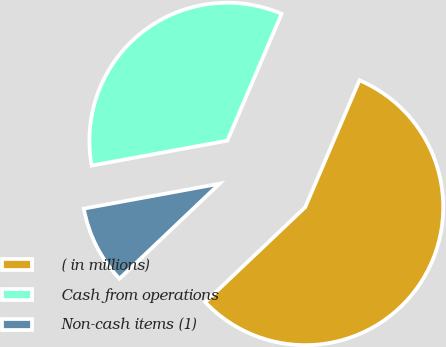<chart> <loc_0><loc_0><loc_500><loc_500><pie_chart><fcel>( in millions)<fcel>Cash from operations<fcel>Non-cash items (1)<nl><fcel>56.48%<fcel>34.32%<fcel>9.2%<nl></chart> 